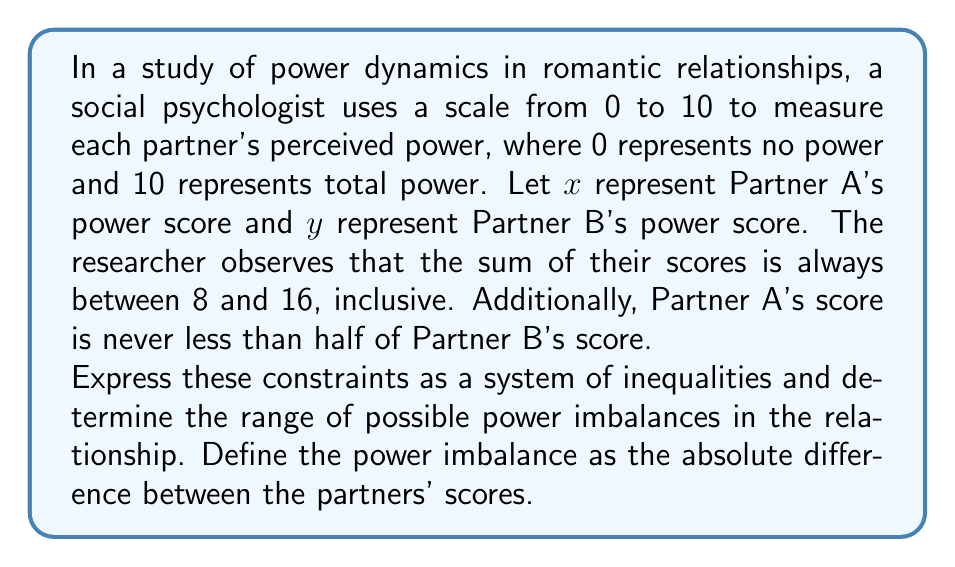Provide a solution to this math problem. Let's approach this step-by-step:

1) First, we need to express the given information as inequalities:

   - The sum of scores is between 8 and 16 (inclusive):
     $$ 8 \leq x + y \leq 16 $$

   - Partner A's score is never less than half of Partner B's score:
     $$ x \geq \frac{1}{2}y $$

   - Both scores are between 0 and 10 (inclusive):
     $$ 0 \leq x \leq 10 $$
     $$ 0 \leq y \leq 10 $$

2) The power imbalance is defined as the absolute difference between scores:
   $$ \text{Power Imbalance} = |x - y| $$

3) To find the range of possible power imbalances, we need to determine the minimum and maximum values of $|x - y|$ that satisfy all constraints.

4) Minimum power imbalance:
   - This occurs when $x = y$, which satisfies $x \geq \frac{1}{2}y$
   - The minimum sum (8) divided equally gives $x = y = 4$
   - Therefore, the minimum power imbalance is 0

5) Maximum power imbalance:
   - This occurs when one partner has the maximum possible score and the other has the minimum possible score that satisfies all constraints
   - If Partner A has the maximum score:
     $x = 10$, and the minimum $y$ that satisfies $8 \leq x + y \leq 16$ is $y = 0$
     However, this doesn't satisfy $x \geq \frac{1}{2}y$, so it's not possible
   - If Partner B has the maximum score:
     $y = 10$, and the minimum $x$ that satisfies both $8 \leq x + y \leq 16$ and $x \geq \frac{1}{2}y$ is $x = 5$
   - Therefore, the maximum power imbalance is $|5 - 10| = 5$

Thus, the range of possible power imbalances is [0, 5].
Answer: The range of possible power imbalances in the relationship is [0, 5]. 